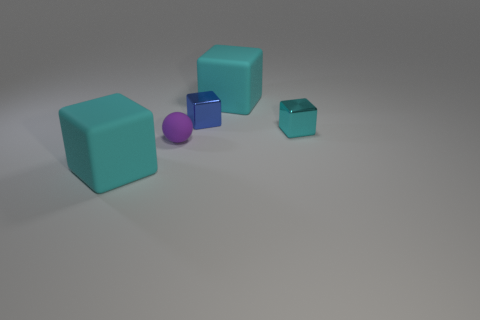Subtract all small blue blocks. How many blocks are left? 3 Add 3 purple objects. How many objects exist? 8 Subtract 4 blocks. How many blocks are left? 0 Subtract all spheres. How many objects are left? 4 Add 5 tiny blue blocks. How many tiny blue blocks exist? 6 Subtract all cyan cubes. How many cubes are left? 1 Subtract 2 cyan blocks. How many objects are left? 3 Subtract all blue spheres. Subtract all yellow cubes. How many spheres are left? 1 Subtract all yellow balls. How many blue blocks are left? 1 Subtract all small metal things. Subtract all small cyan metallic cubes. How many objects are left? 2 